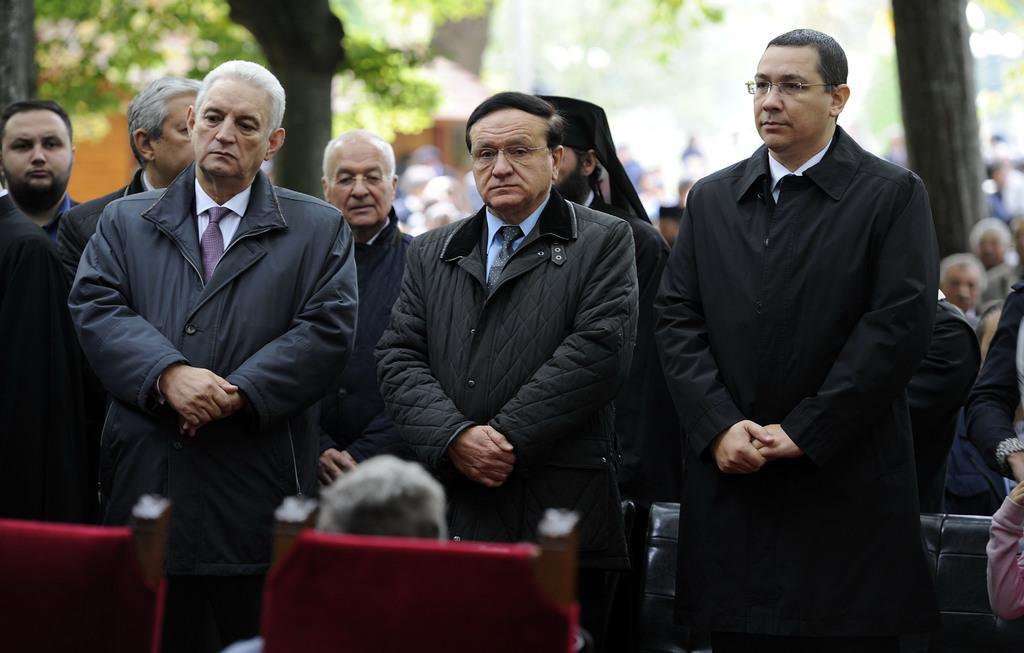How would you summarize this image in a sentence or two? In this image there are group of people standing together, also there are so many people around where we can see there are so many trees behind them. 